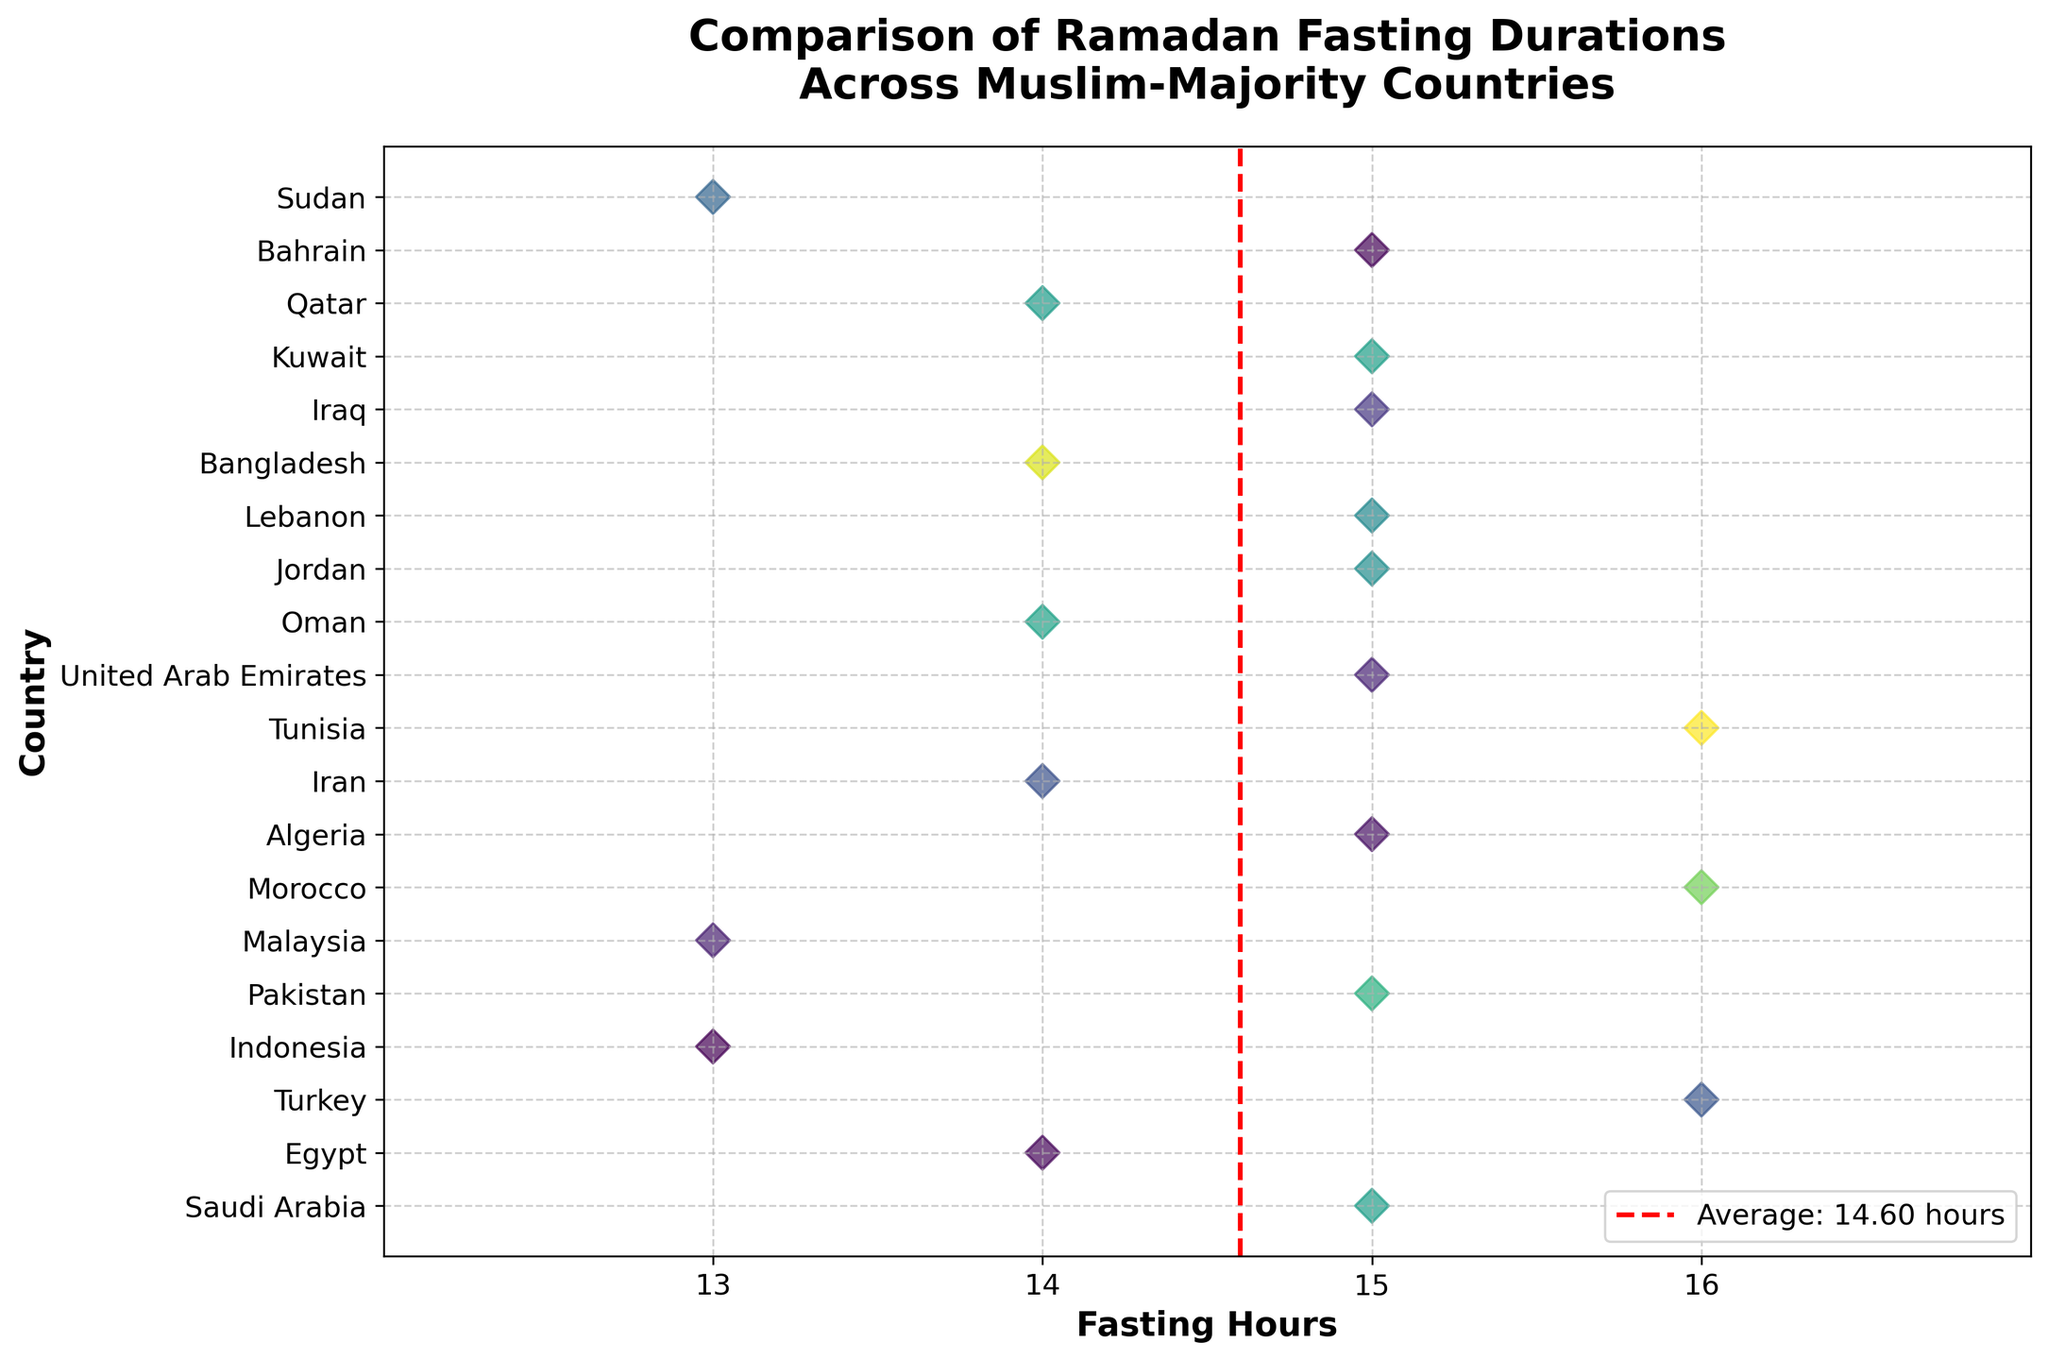What is the title of the figure? The title is prominently displayed at the top of the figure.
Answer: Comparison of Ramadan Fasting Durations Across Muslim-Majority Countries How many countries are included in the plot? By counting the number of unique data points (dots) plotted along the y-axis, which represents different countries.
Answer: 20 Which country has the shortest fasting duration? By identifying the lowermost data point on the x-axis, which corresponds to the fasting duration in hours.
Answer: Indonesia and Malaysia What is the average fasting duration and how is it depicted on the plot? The average fasting duration is calculated as the mean of all fasting hours and is visually represented by a vertical red dashed line on the plot.
Answer: 14.55 hours Which countries have fasting durations greater than 15 hours? By identifying the data points to the right of the 15-hour mark along the x-axis.
Answer: Turkey, Morocco, and Tunisia How does the fasting duration of Egypt compare to that of Iran? By locating the data points for Egypt and Iran along the x-axis and comparing their positions relative to each other.
Answer: They both have fasting durations of 14 hours What is the fasting duration for Oman and how does it compare with the average fasting duration? Find the data point for Oman and compare its x-axis value to the average, indicated by the red dashed line.
Answer: Oman's fasting duration is 14 hours, which is less than the average of 14.55 hours What is the range of fasting durations represented in the plot? By finding the difference between the maximum and minimum values along the x-axis.
Answer: 3 hours (16 - 13) How many countries have a fasting duration exactly equal to 15 hours? By counting the data points along the 15-hour vertical line on the x-axis.
Answer: 9 Based on the plot, which fasting duration appears most frequently among the countries? By identifying the fasting duration along the x-axis that has the highest concentration of data points.
Answer: 15 hours 